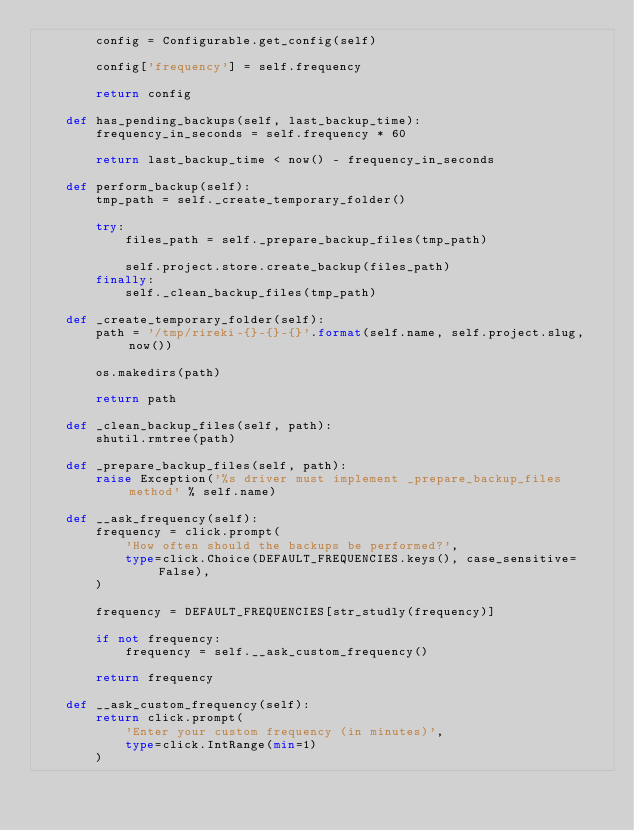Convert code to text. <code><loc_0><loc_0><loc_500><loc_500><_Python_>        config = Configurable.get_config(self)

        config['frequency'] = self.frequency

        return config

    def has_pending_backups(self, last_backup_time):
        frequency_in_seconds = self.frequency * 60

        return last_backup_time < now() - frequency_in_seconds

    def perform_backup(self):
        tmp_path = self._create_temporary_folder()

        try:
            files_path = self._prepare_backup_files(tmp_path)

            self.project.store.create_backup(files_path)
        finally:
            self._clean_backup_files(tmp_path)

    def _create_temporary_folder(self):
        path = '/tmp/rireki-{}-{}-{}'.format(self.name, self.project.slug, now())

        os.makedirs(path)

        return path

    def _clean_backup_files(self, path):
        shutil.rmtree(path)

    def _prepare_backup_files(self, path):
        raise Exception('%s driver must implement _prepare_backup_files method' % self.name)

    def __ask_frequency(self):
        frequency = click.prompt(
            'How often should the backups be performed?',
            type=click.Choice(DEFAULT_FREQUENCIES.keys(), case_sensitive=False),
        )

        frequency = DEFAULT_FREQUENCIES[str_studly(frequency)]

        if not frequency:
            frequency = self.__ask_custom_frequency()

        return frequency

    def __ask_custom_frequency(self):
        return click.prompt(
            'Enter your custom frequency (in minutes)',
            type=click.IntRange(min=1)
        )
</code> 